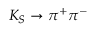<formula> <loc_0><loc_0><loc_500><loc_500>K _ { S } \rightarrow \pi ^ { + } \pi ^ { - }</formula> 